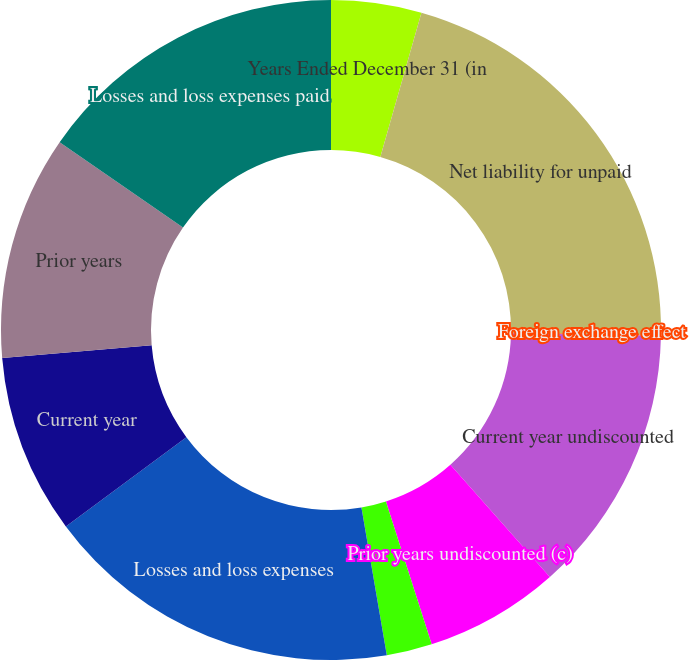Convert chart to OTSL. <chart><loc_0><loc_0><loc_500><loc_500><pie_chart><fcel>Years Ended December 31 (in<fcel>Net liability for unpaid<fcel>Foreign exchange effect<fcel>Current year undiscounted<fcel>Prior years undiscounted (c)<fcel>Change in discount<fcel>Losses and loss expenses<fcel>Current year<fcel>Prior years<fcel>Losses and loss expenses paid<nl><fcel>4.42%<fcel>20.83%<fcel>0.04%<fcel>13.18%<fcel>6.61%<fcel>2.23%<fcel>17.56%<fcel>8.8%<fcel>10.99%<fcel>15.37%<nl></chart> 